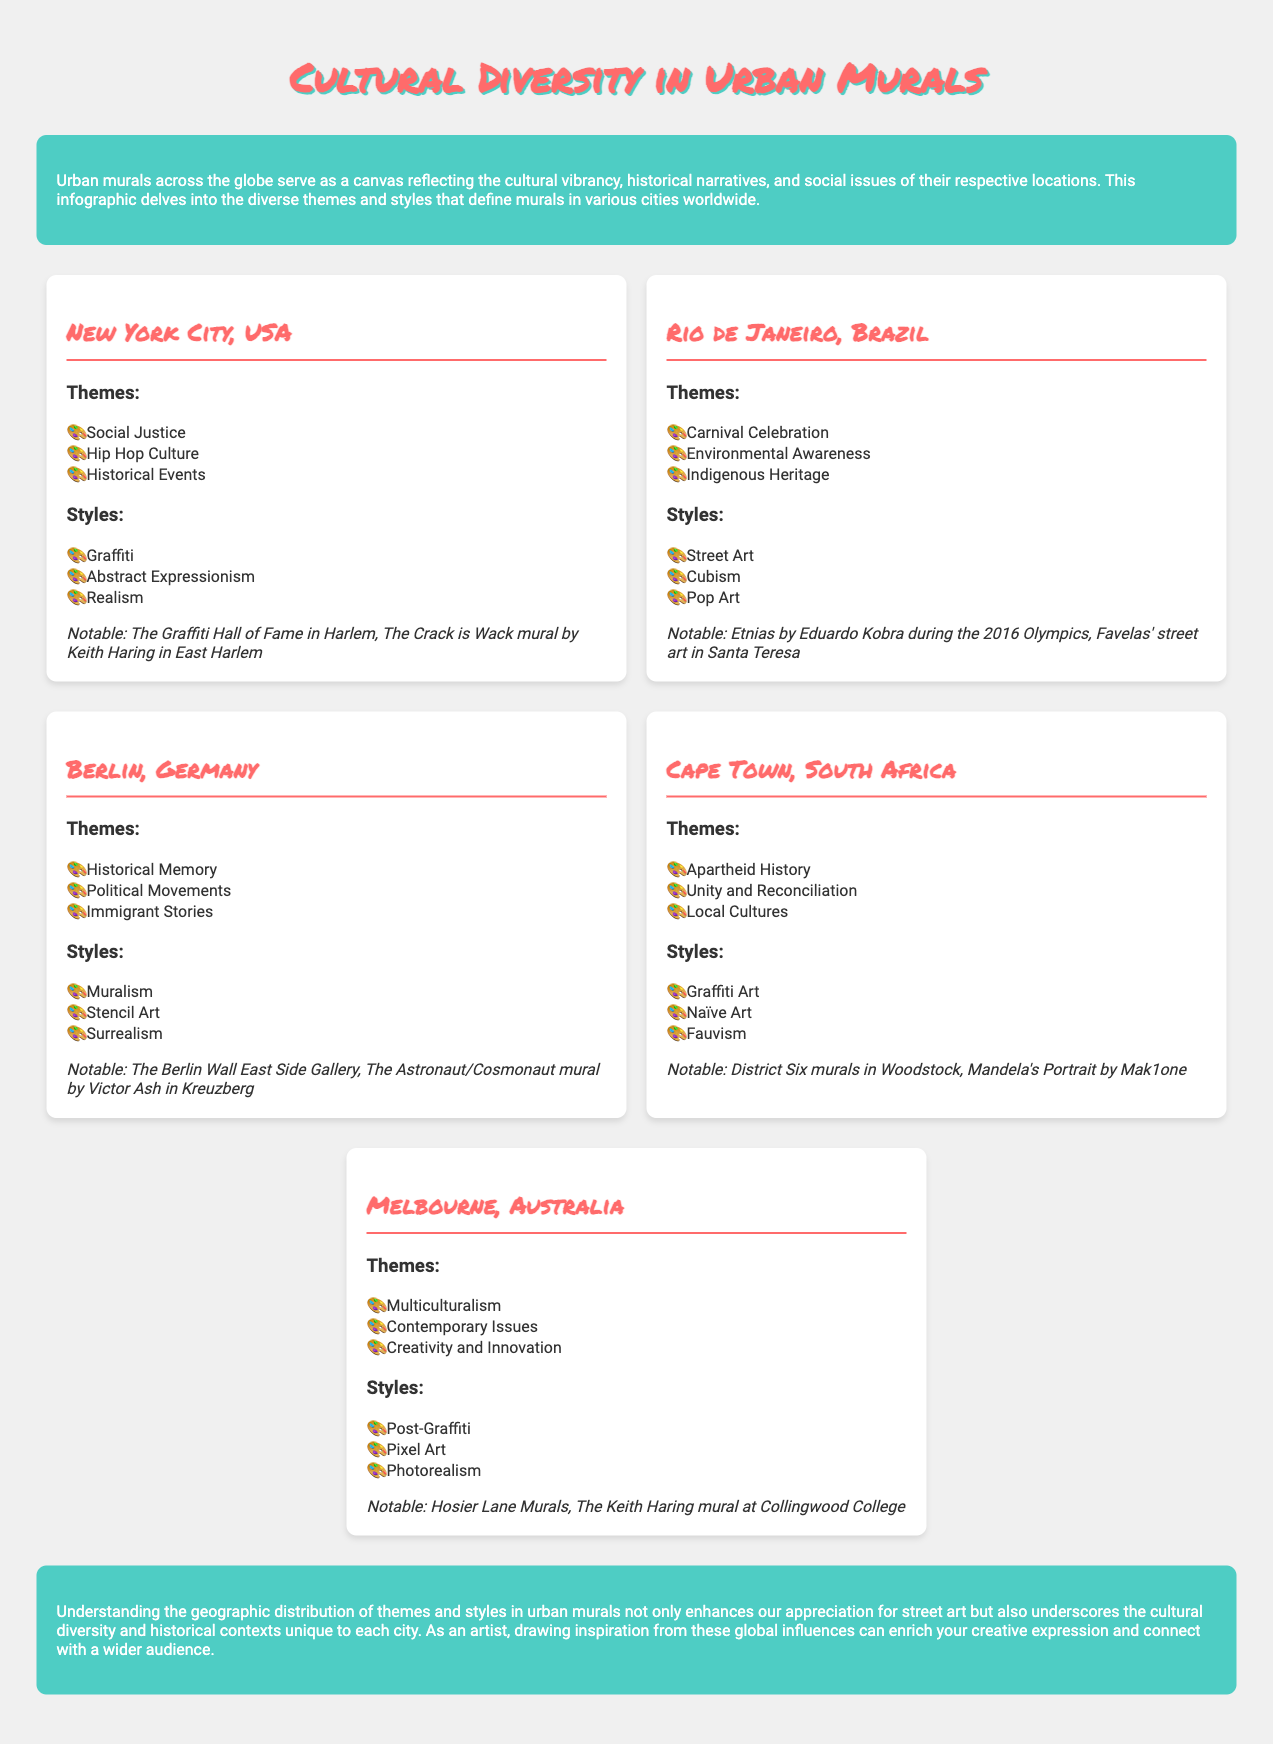What are the notable murals in New York City? The notable murals include The Graffiti Hall of Fame in Harlem and The Crack is Wack mural by Keith Haring in East Harlem.
Answer: The Graffiti Hall of Fame in Harlem, The Crack is Wack mural by Keith Haring in East Harlem Which city features themes of Carnival Celebration? The document states that Rio de Janeiro, Brazil features themes of Carnival Celebration.
Answer: Rio de Janeiro, Brazil What art style is associated with Cape Town? The styles mentioned for Cape Town include Graffiti Art, Naïve Art, and Fauvism.
Answer: Graffiti Art How many cities are discussed in the infographic? The infographic details urban murals across five cities.
Answer: Five What is the primary theme of murals in Berlin? The primary themes include Historical Memory, Political Movements, and Immigrant Stories.
Answer: Historical Memory Which city highlights Multiculturalism as a theme? The infographic indicates that Melbourne, Australia highlights Multiculturalism as a theme.
Answer: Melbourne, Australia What is a notable mural in Rio de Janeiro? Notable murals include Etnias by Eduardo Kobra during the 2016 Olympics.
Answer: Etnias by Eduardo Kobra during the 2016 Olympics What artistic style is prominent in Melbourne? The styles associated with Melbourne include Post-Graffiti, Pixel Art, and Photorealism.
Answer: Post-Graffiti Which city is linked with Apartheid History? The infographic mentions that Cape Town, South Africa is linked with Apartheid History.
Answer: Cape Town, South Africa 